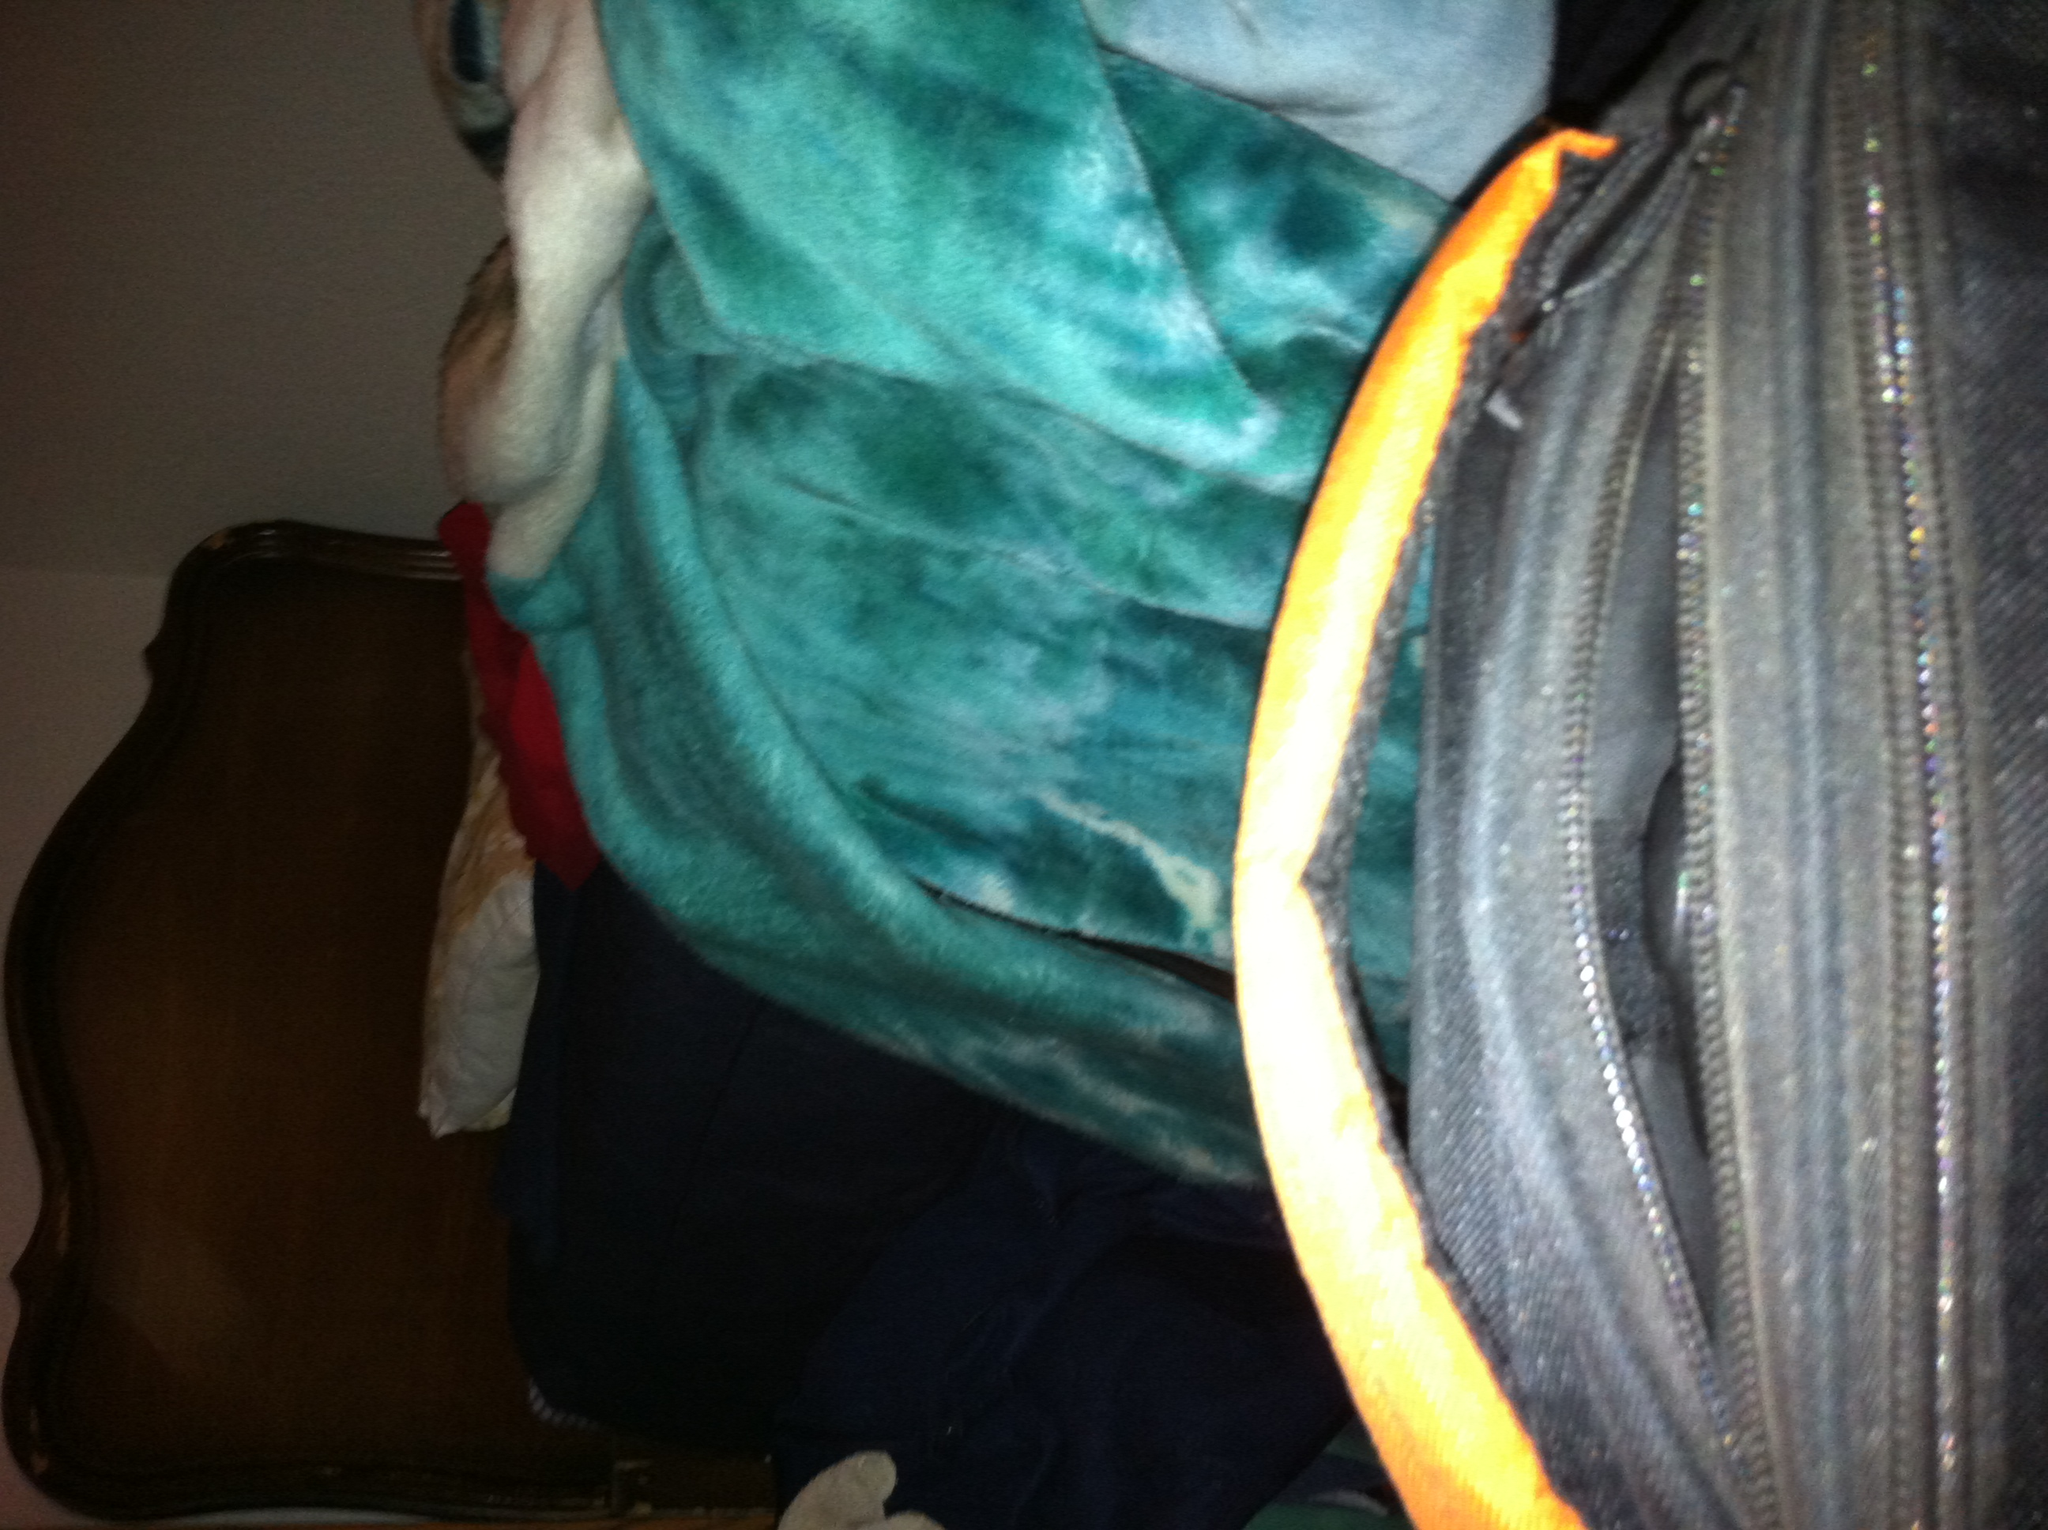What material does the bag appear to be made from? The bag appears to be made of a sturdy, woven fabric, possibly nylon or a similar synthetic material, suitable for everyday use and resistant to wear. 